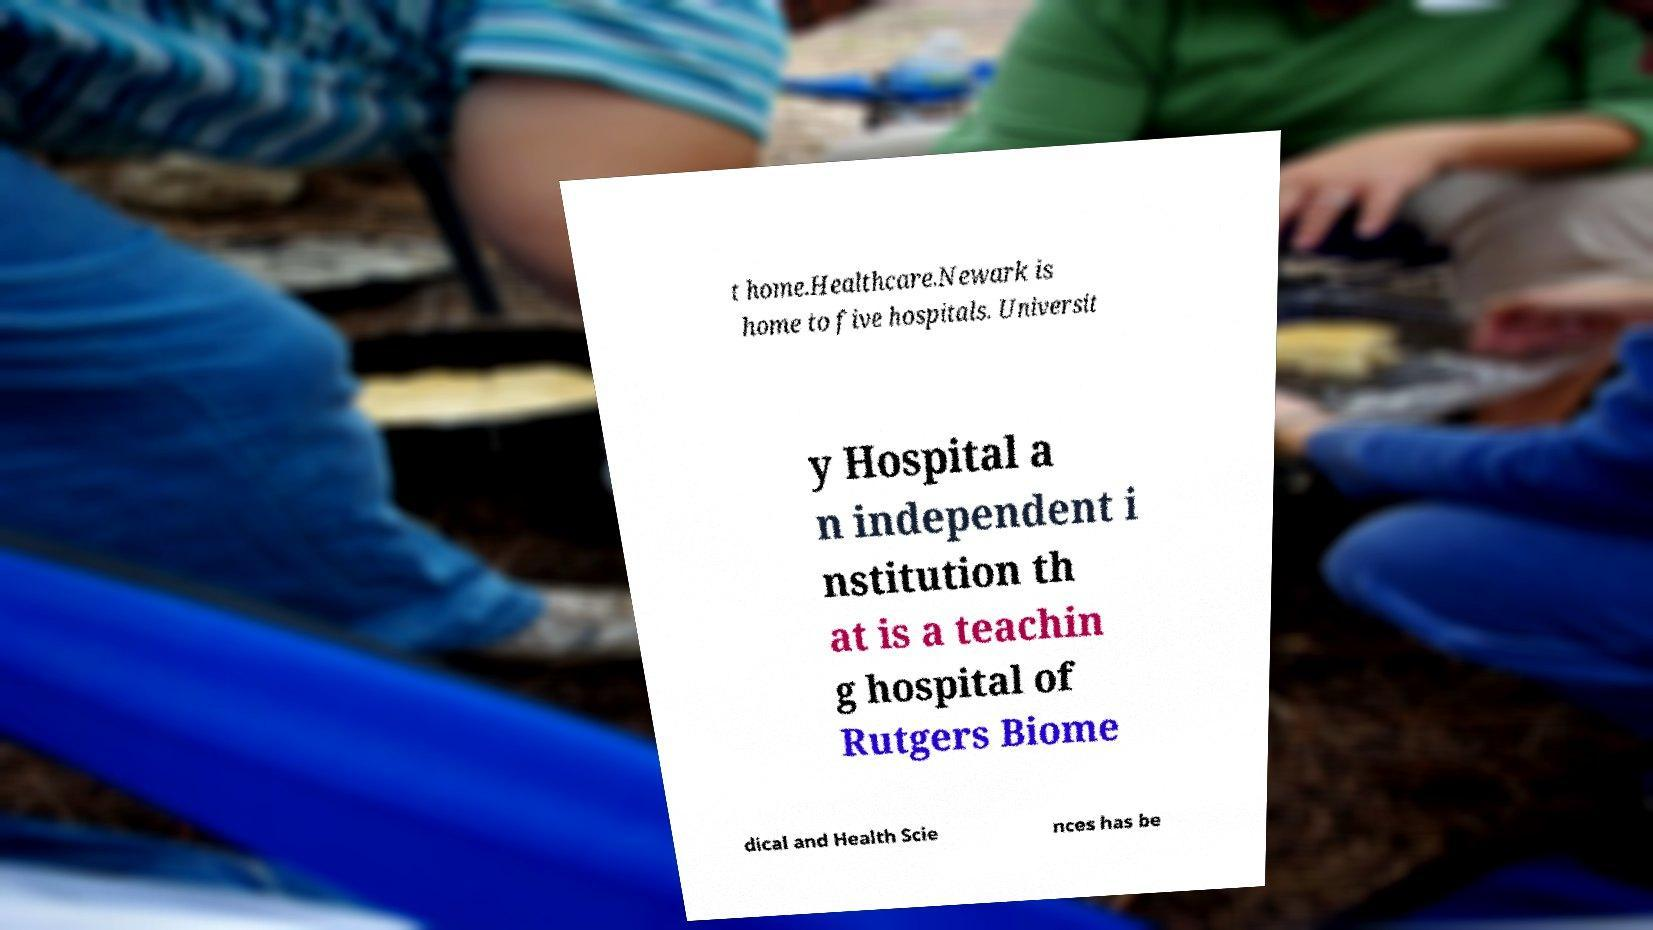Could you assist in decoding the text presented in this image and type it out clearly? t home.Healthcare.Newark is home to five hospitals. Universit y Hospital a n independent i nstitution th at is a teachin g hospital of Rutgers Biome dical and Health Scie nces has be 